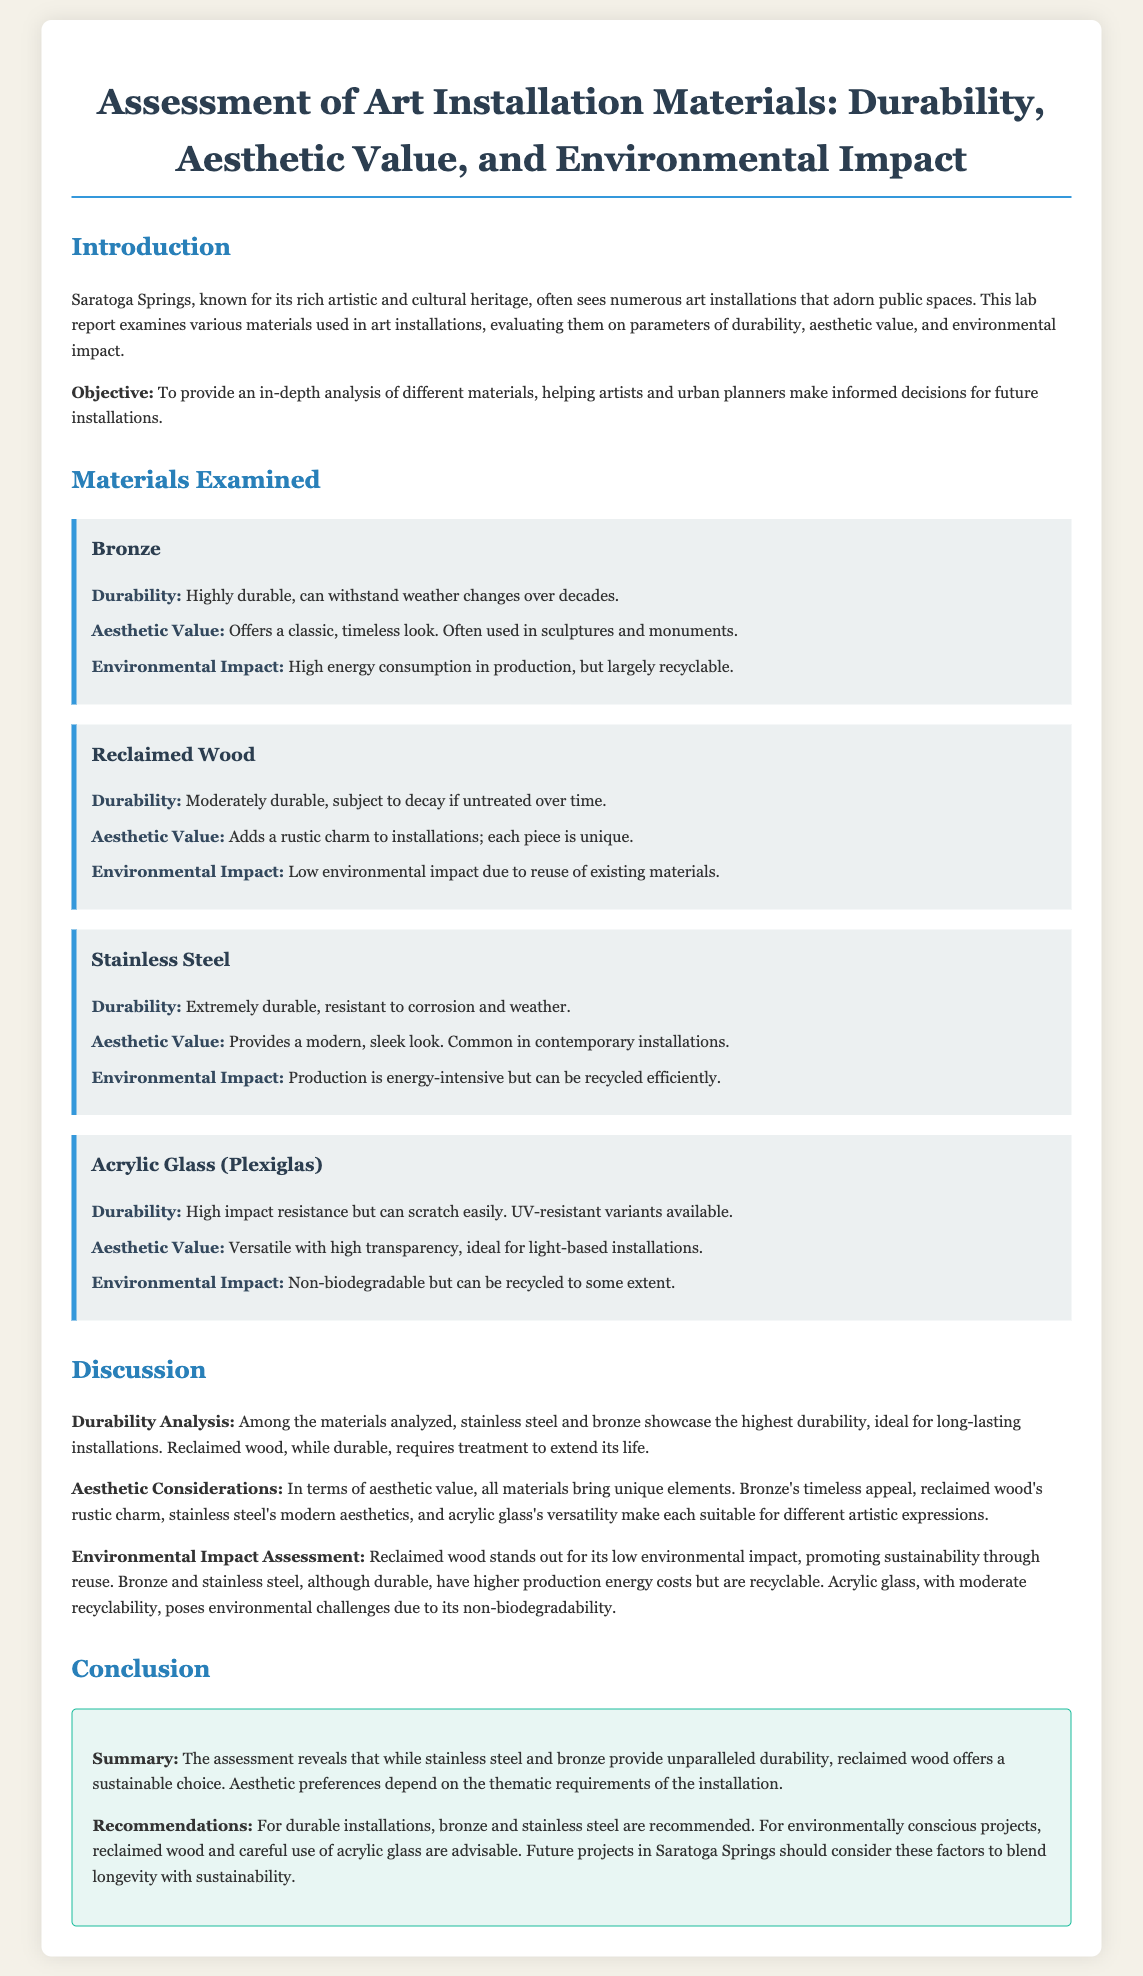What is the main objective of the report? The objective is stated in the introduction, focusing on analyzing materials to aid decision-making for future installations.
Answer: To provide an in-depth analysis of different materials What is the aesthetic value of Bronze? The aesthetic value of Bronze is detailed in the section about its properties, describing its visual appeal.
Answer: Offers a classic, timeless look How durable is Stainless Steel? Durability is listed in the properties of Stainless Steel, indicating its longevity and resistance characteristics.
Answer: Extremely durable What environmental impact does Reclaimed Wood have? The environmental impact is summarized in the properties section for Reclaimed Wood, highlighting its sustainability aspect.
Answer: Low environmental impact due to reuse Which material stands out for its low environmental impact? The discussion mentions this material specifically when addressing environmental considerations in art installation materials.
Answer: Reclaimed Wood What are the recommendations for durable installations? The conclusion provides clear guidance on what materials to use for longevity based on the analysis presented.
Answer: Bronze and Stainless Steel Which material is described as having high impact resistance? This characteristic is mentioned in the section detailing the properties of one of the materials.
Answer: Acrylic Glass (Plexiglas) What is a characteristic of the aesthetic value of Acrylic Glass? The aesthetic aspect is highlighted in the properties section, pointing out its visual qualities.
Answer: Versatile with high transparency 